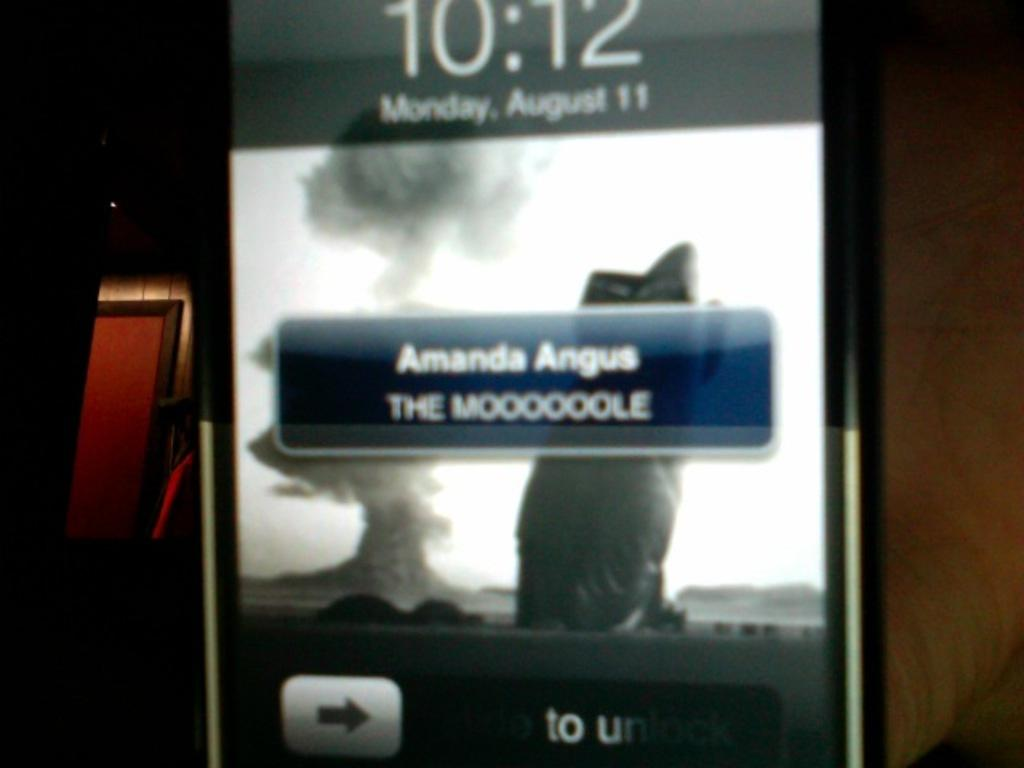<image>
Offer a succinct explanation of the picture presented. An electronic device that says Amanda Angus in the middle of the screen. 